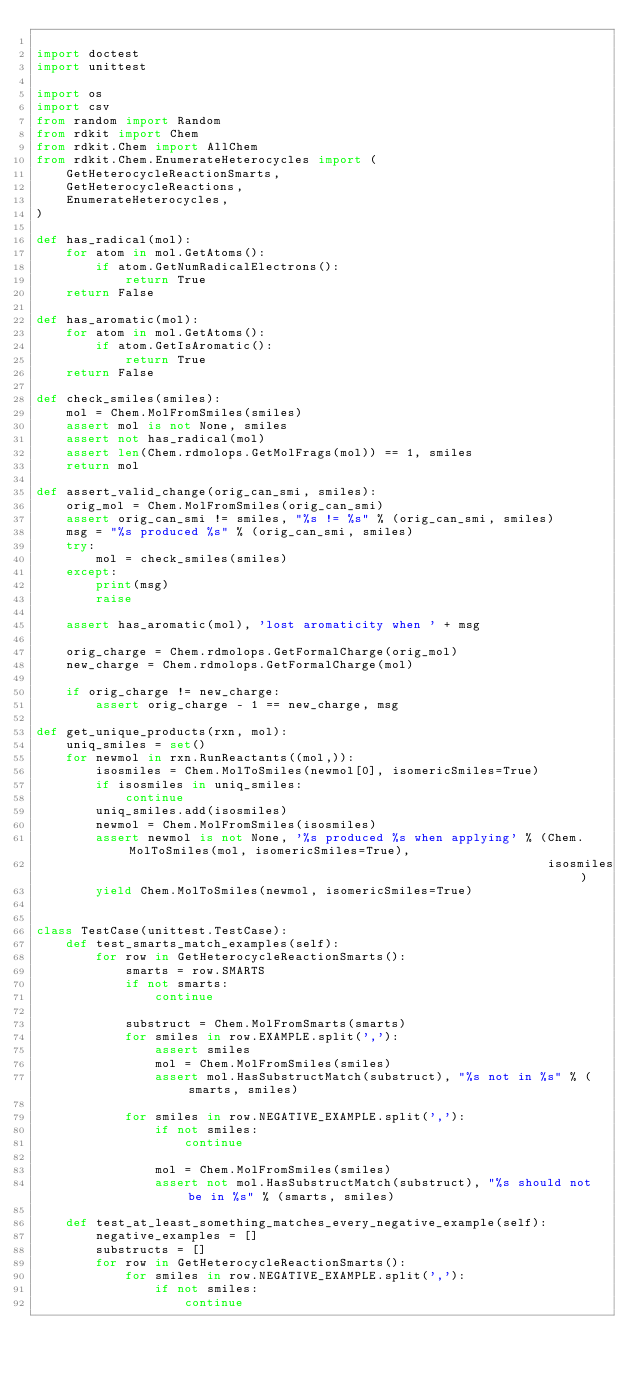Convert code to text. <code><loc_0><loc_0><loc_500><loc_500><_Python_>
import doctest
import unittest

import os
import csv
from random import Random
from rdkit import Chem
from rdkit.Chem import AllChem
from rdkit.Chem.EnumerateHeterocycles import (
    GetHeterocycleReactionSmarts,
    GetHeterocycleReactions,
    EnumerateHeterocycles,
)

def has_radical(mol):
    for atom in mol.GetAtoms():
        if atom.GetNumRadicalElectrons():
            return True
    return False

def has_aromatic(mol):
    for atom in mol.GetAtoms():
        if atom.GetIsAromatic():
            return True
    return False

def check_smiles(smiles):
    mol = Chem.MolFromSmiles(smiles)
    assert mol is not None, smiles
    assert not has_radical(mol)
    assert len(Chem.rdmolops.GetMolFrags(mol)) == 1, smiles
    return mol

def assert_valid_change(orig_can_smi, smiles):
    orig_mol = Chem.MolFromSmiles(orig_can_smi)
    assert orig_can_smi != smiles, "%s != %s" % (orig_can_smi, smiles)
    msg = "%s produced %s" % (orig_can_smi, smiles)
    try:
        mol = check_smiles(smiles)
    except:
        print(msg)
        raise

    assert has_aromatic(mol), 'lost aromaticity when ' + msg

    orig_charge = Chem.rdmolops.GetFormalCharge(orig_mol)
    new_charge = Chem.rdmolops.GetFormalCharge(mol)

    if orig_charge != new_charge:
        assert orig_charge - 1 == new_charge, msg

def get_unique_products(rxn, mol):
    uniq_smiles = set()
    for newmol in rxn.RunReactants((mol,)):
        isosmiles = Chem.MolToSmiles(newmol[0], isomericSmiles=True)
        if isosmiles in uniq_smiles:
            continue
        uniq_smiles.add(isosmiles)
        newmol = Chem.MolFromSmiles(isosmiles)
        assert newmol is not None, '%s produced %s when applying' % (Chem.MolToSmiles(mol, isomericSmiles=True),
                                                                     isosmiles)
        yield Chem.MolToSmiles(newmol, isomericSmiles=True)


class TestCase(unittest.TestCase):
    def test_smarts_match_examples(self):
        for row in GetHeterocycleReactionSmarts():
            smarts = row.SMARTS
            if not smarts:
                continue

            substruct = Chem.MolFromSmarts(smarts)
            for smiles in row.EXAMPLE.split(','):
                assert smiles
                mol = Chem.MolFromSmiles(smiles)
                assert mol.HasSubstructMatch(substruct), "%s not in %s" % (smarts, smiles)

            for smiles in row.NEGATIVE_EXAMPLE.split(','):
                if not smiles:
                    continue

                mol = Chem.MolFromSmiles(smiles)
                assert not mol.HasSubstructMatch(substruct), "%s should not be in %s" % (smarts, smiles)

    def test_at_least_something_matches_every_negative_example(self):
        negative_examples = []
        substructs = []
        for row in GetHeterocycleReactionSmarts():
            for smiles in row.NEGATIVE_EXAMPLE.split(','):
                if not smiles:
                    continue</code> 